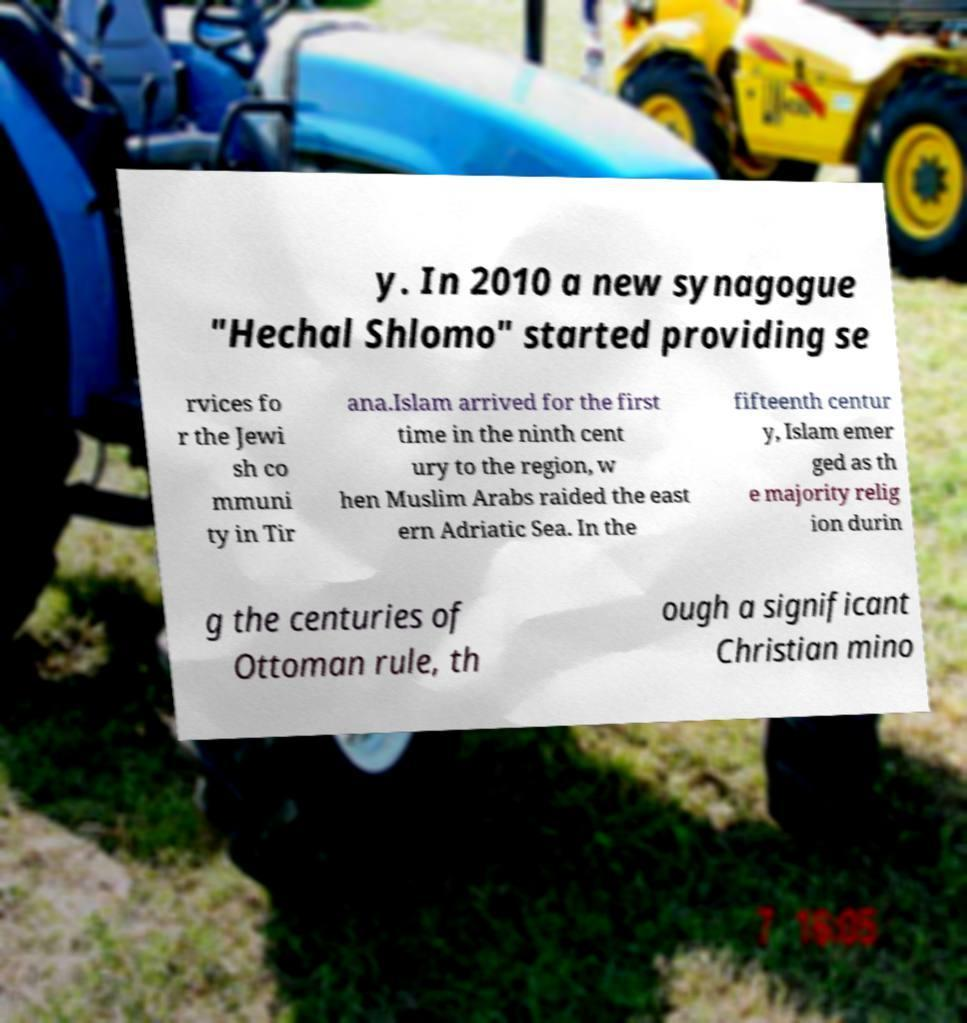I need the written content from this picture converted into text. Can you do that? y. In 2010 a new synagogue "Hechal Shlomo" started providing se rvices fo r the Jewi sh co mmuni ty in Tir ana.Islam arrived for the first time in the ninth cent ury to the region, w hen Muslim Arabs raided the east ern Adriatic Sea. In the fifteenth centur y, Islam emer ged as th e majority relig ion durin g the centuries of Ottoman rule, th ough a significant Christian mino 